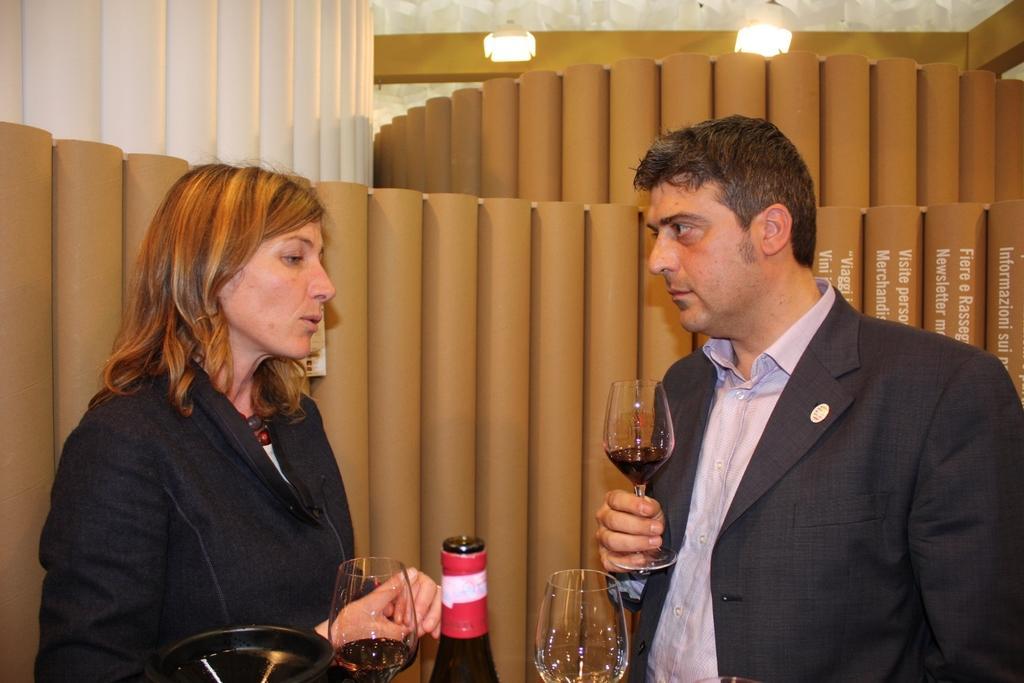How would you summarize this image in a sentence or two? In this image I can see a woman and a man who are holding one wine glass in their hands. I can also see a glass bottle and wine glass in front of them. 